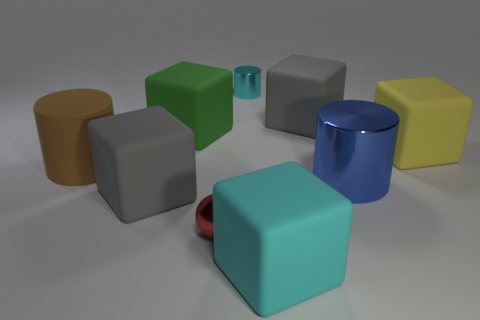Are there more cyan shiny cylinders than metal cylinders? no 